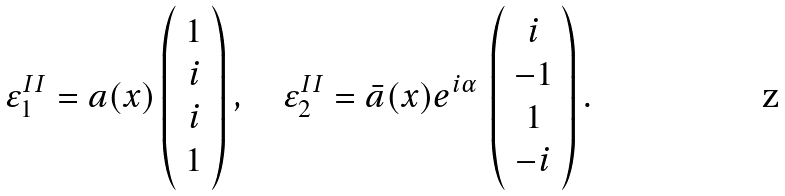<formula> <loc_0><loc_0><loc_500><loc_500>\varepsilon _ { 1 } ^ { I I } = a ( x ) \left ( \begin{array} { c } 1 \\ i \\ i \\ 1 \end{array} \right ) , \quad \varepsilon _ { 2 } ^ { I I } = { \bar { a } ( x ) } e ^ { i \alpha } \, \left ( \begin{array} { c } i \\ - 1 \\ 1 \\ - i \end{array} \right ) .</formula> 